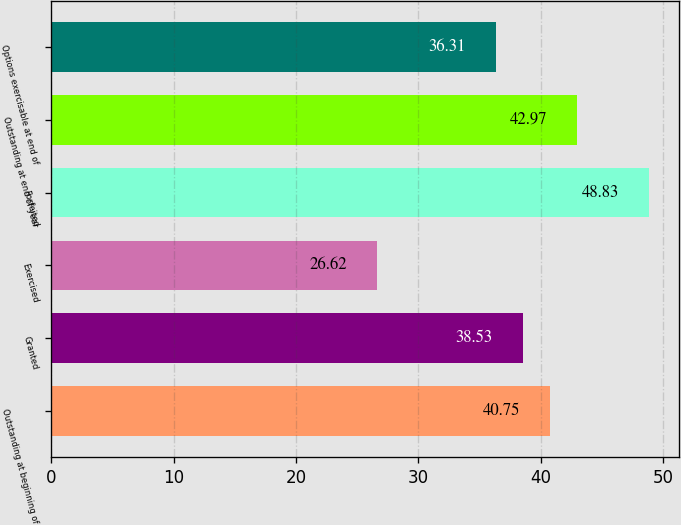Convert chart. <chart><loc_0><loc_0><loc_500><loc_500><bar_chart><fcel>Outstanding at beginning of<fcel>Granted<fcel>Exercised<fcel>Forfeited<fcel>Outstanding at end of year<fcel>Options exercisable at end of<nl><fcel>40.75<fcel>38.53<fcel>26.62<fcel>48.83<fcel>42.97<fcel>36.31<nl></chart> 